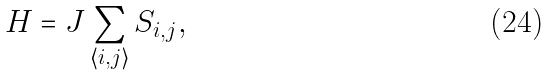<formula> <loc_0><loc_0><loc_500><loc_500>H = J \sum _ { \langle i , j \rangle } S _ { i , j } ,</formula> 